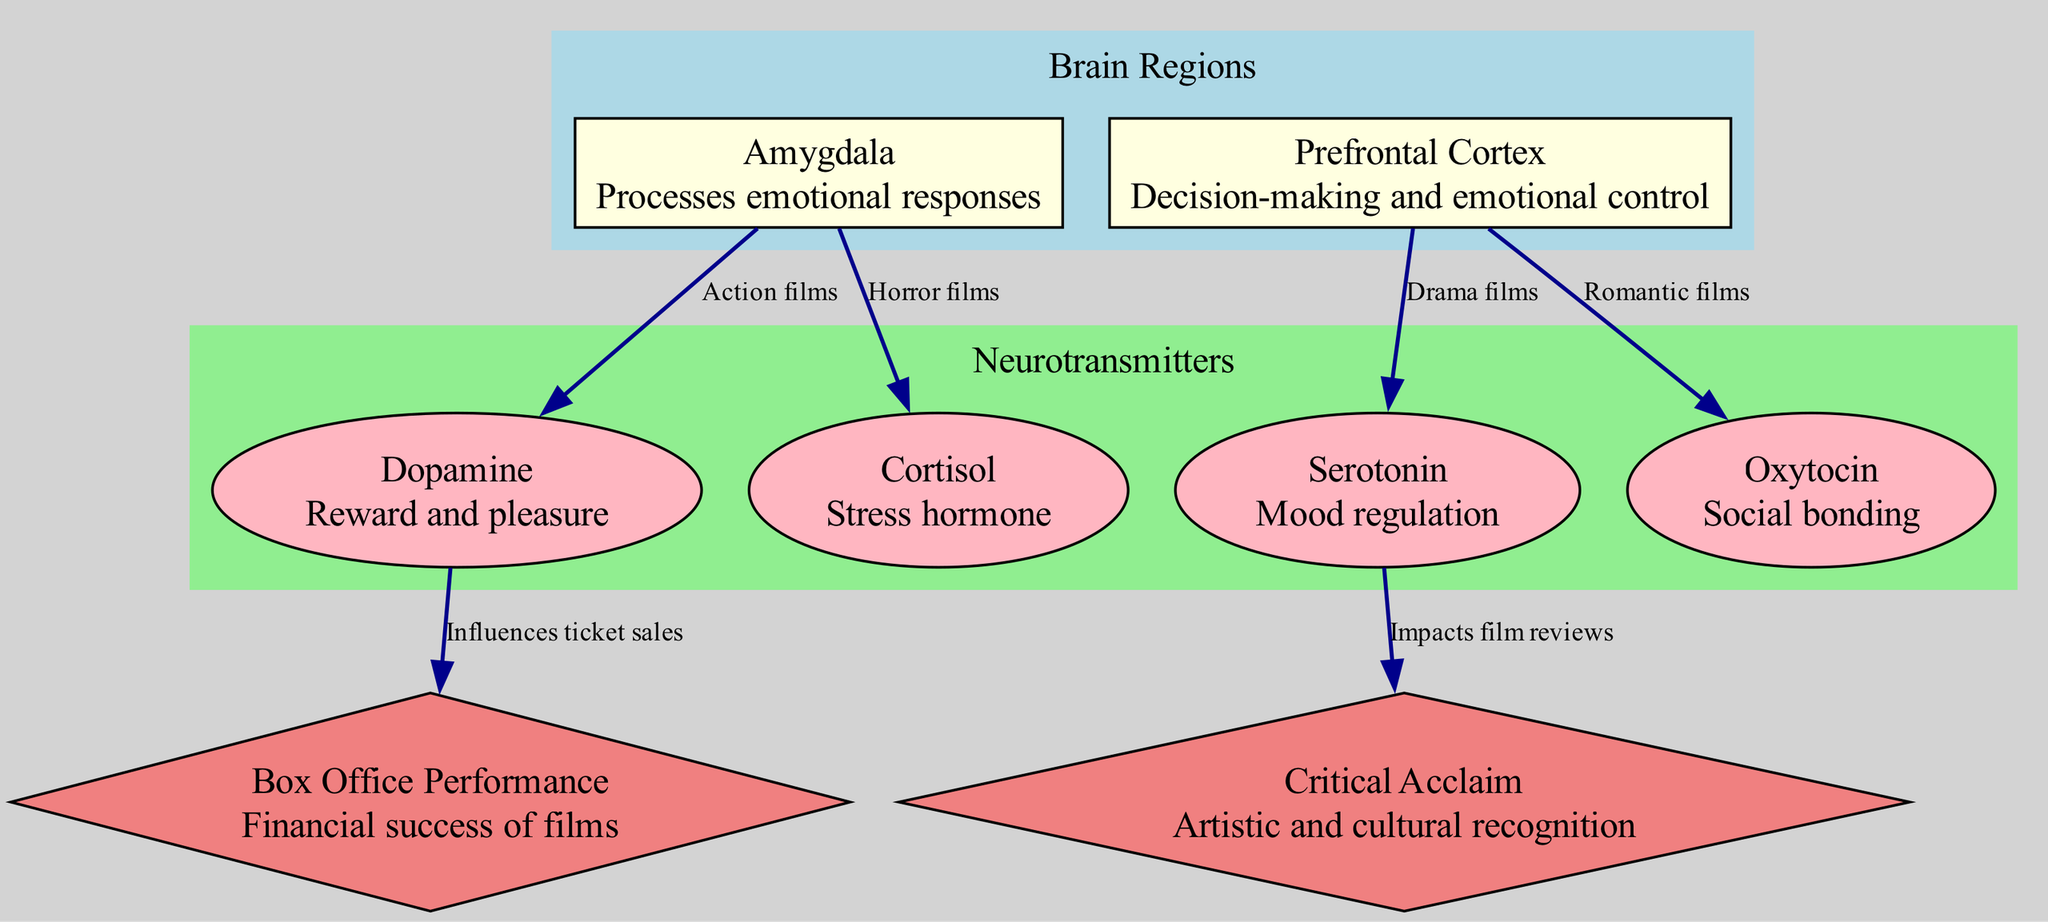What brain region processes emotional responses? The diagram indicates that the amygdala is the primary brain region responsible for processing emotional responses, as labeled in the node description.
Answer: Amygdala Which neurotransmitter is associated with mood regulation? According to the information in the diagram, serotonin is specifically described as being responsible for mood regulation, which can be found in the node details.
Answer: Serotonin How many edges are present in the diagram? By counting the edges that represent relationships between nodes in the diagram, there are a total of six edges connecting various brain regions and neurotransmitters.
Answer: 6 What film genre influences cortisol levels? The diagram shows a direct edge from the amygdala to cortisol, labeled as being influenced by horror films, indicating that horror films impact cortisol levels.
Answer: Horror films Which neurotransmitter impacts film reviews? The diagram specifies that serotonin has a relationship with critical acclaim, indicating that this neurotransmitter impacts film reviews as depicted in the edge connection.
Answer: Serotonin What is the financial success of films related to? The diagram illustrates that dopamine is connected to box office performance, meaning that this neurotransmitter influences the financial success of films as shown in the edge description.
Answer: Influences ticket sales Which brain region is involved in decision-making and emotional control? The diagram explicitly labels the prefrontal cortex as the brain region associated with decision-making and emotional control, as stated in its description.
Answer: Prefrontal Cortex Which film genre is connected to social bonding? The diagram demonstrates a connection from the prefrontal cortex to oxytocin, indicating that romantic films are associated with social bonding according to the label on the edge.
Answer: Romantic films What type of acclaim does serotonin impact? Per the edge in the diagram, serotonin is shown to influence critical acclaim, indicating its role in impacting artistic and cultural recognition of films.
Answer: Critical Acclaim 